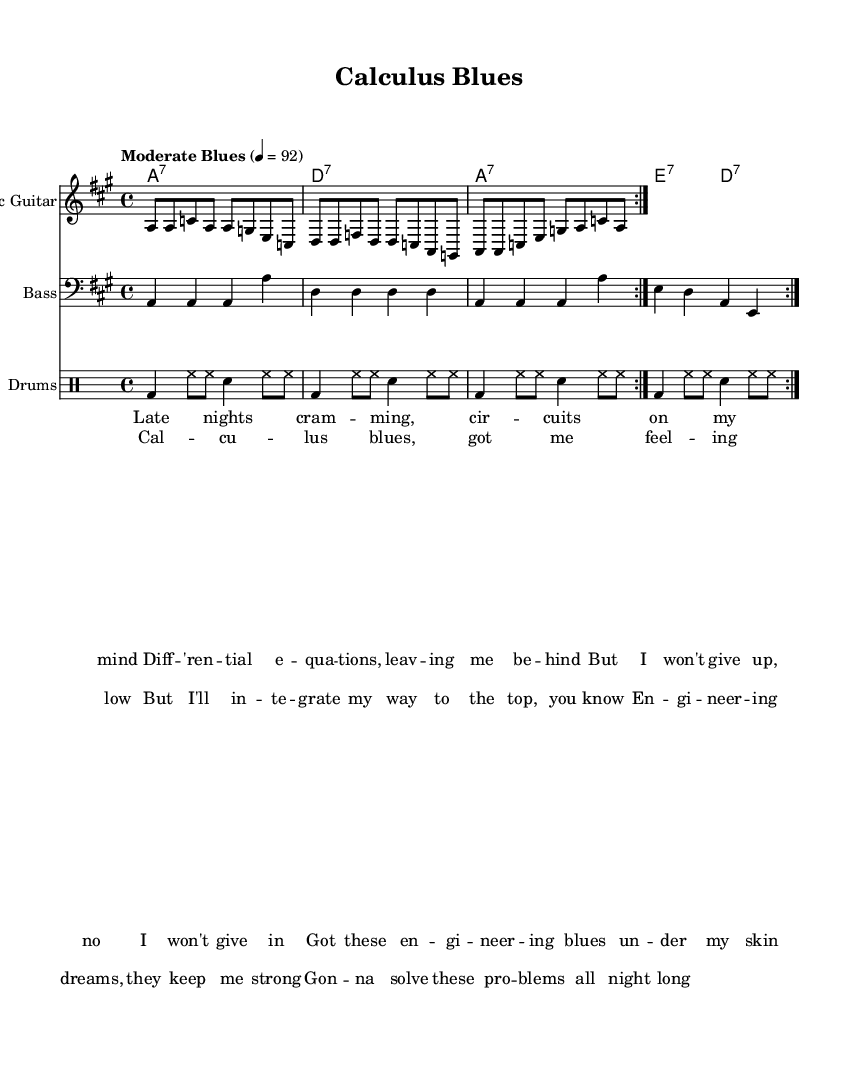What is the key signature of this music? The key signature is A major, indicated by three sharps (F#, C#, G#), which can be identified by the sharp symbols at the beginning of the staff.
Answer: A major What is the time signature? The time signature is 4/4, as indicated at the beginning of the piece, which means there are four beats in a measure.
Answer: 4/4 What is the tempo marking of this piece? The tempo marking is "Moderate Blues," which suggests a laid-back, steady tempo that sets the mood for blues music.
Answer: Moderate Blues How many bars are repeated in the electric guitar section? The electric guitar section contains a repeated pattern of two bars, as indicated by the "repeat volta 2" markings in the score.
Answer: 2 What instrument is playing the bass line? The bass line is played by the instrument labeled "Bass," which is specified in the staff's header.
Answer: Bass What is the theme expressed in the lyrics? The theme expressed in the lyrics revolves around the struggles and determination of an engineering student, highlighting late-night studying and perseverance.
Answer: Struggles and determination Identify the role of the drums in this music. The drums provide a rhythmic foundation and maintain a steady beat throughout the piece, essential for the blues genre to drive the music forward.
Answer: Rhythmic foundation 